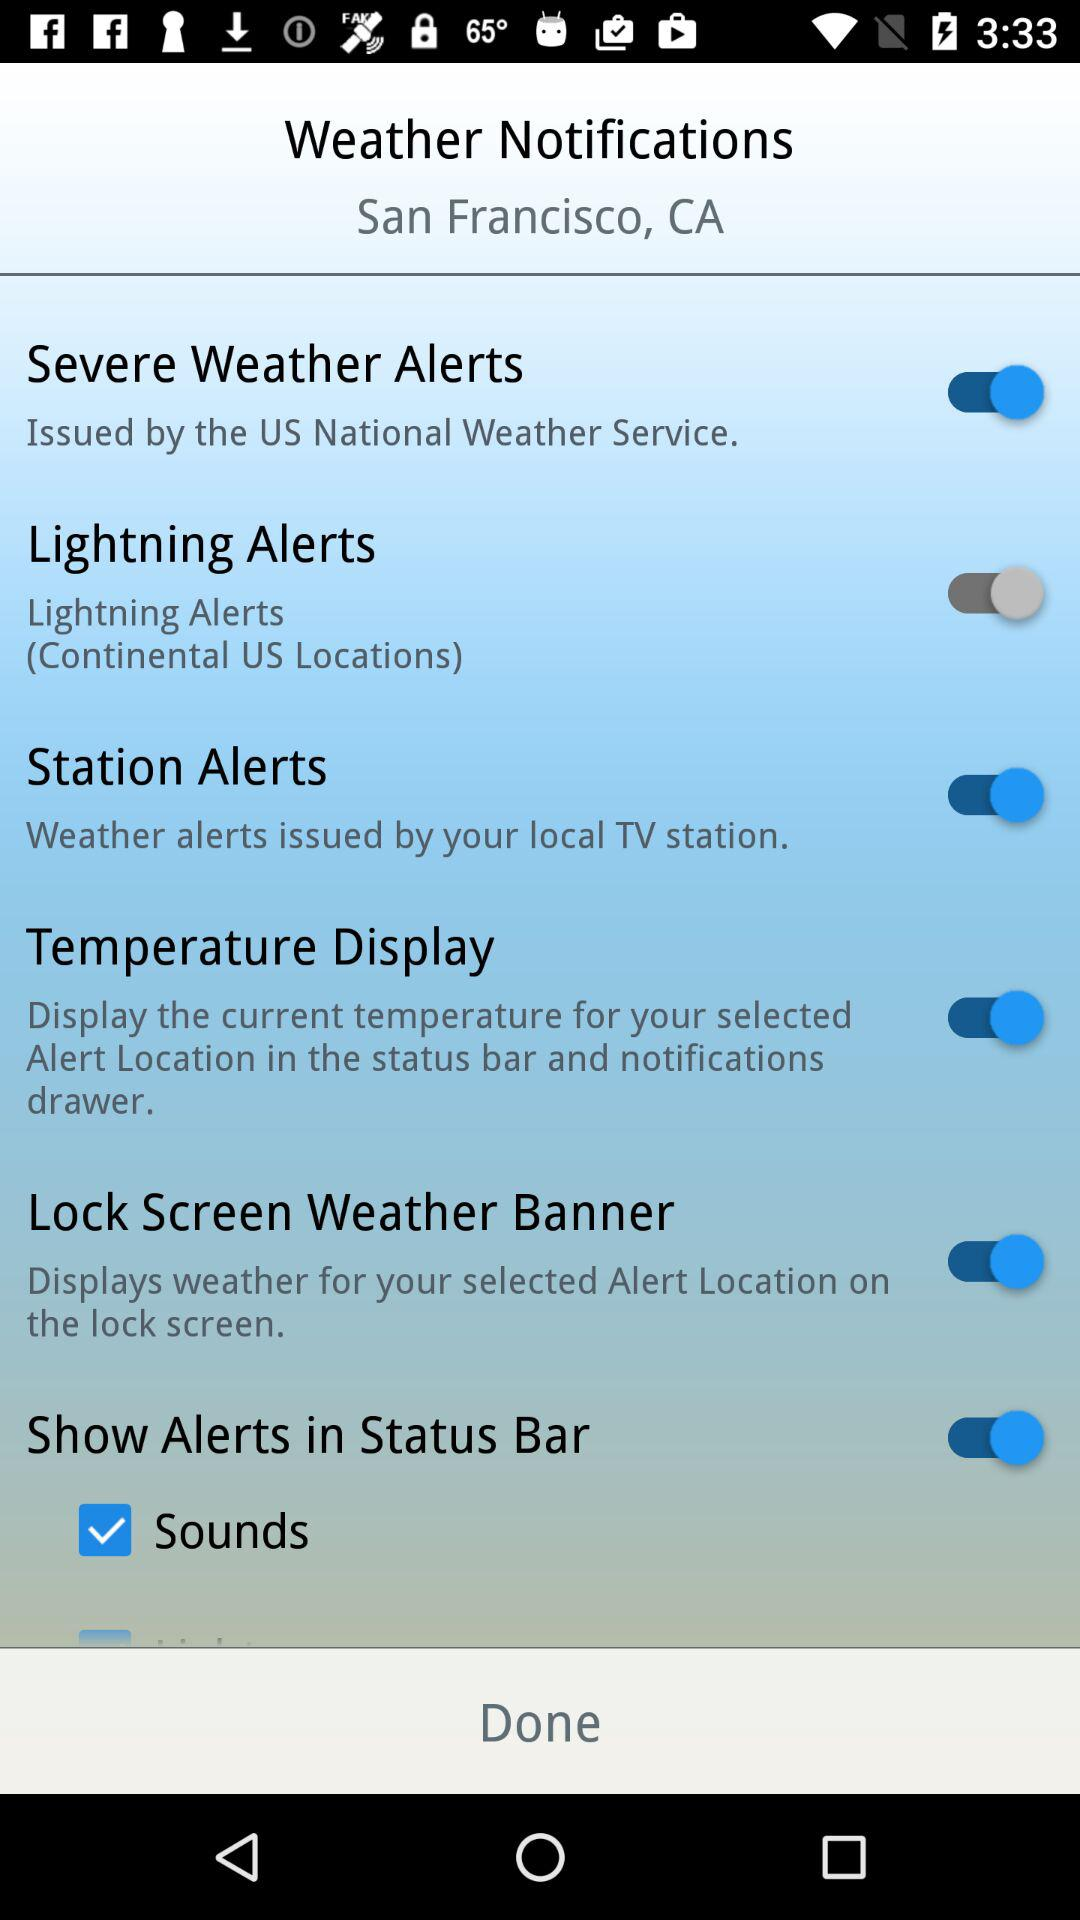What is the location for weather notifications? The location for weather notifications is San Francisco, CA. 